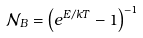<formula> <loc_0><loc_0><loc_500><loc_500>\mathcal { N } _ { B } = \left ( e ^ { E / k T } - 1 \right ) ^ { - 1 }</formula> 